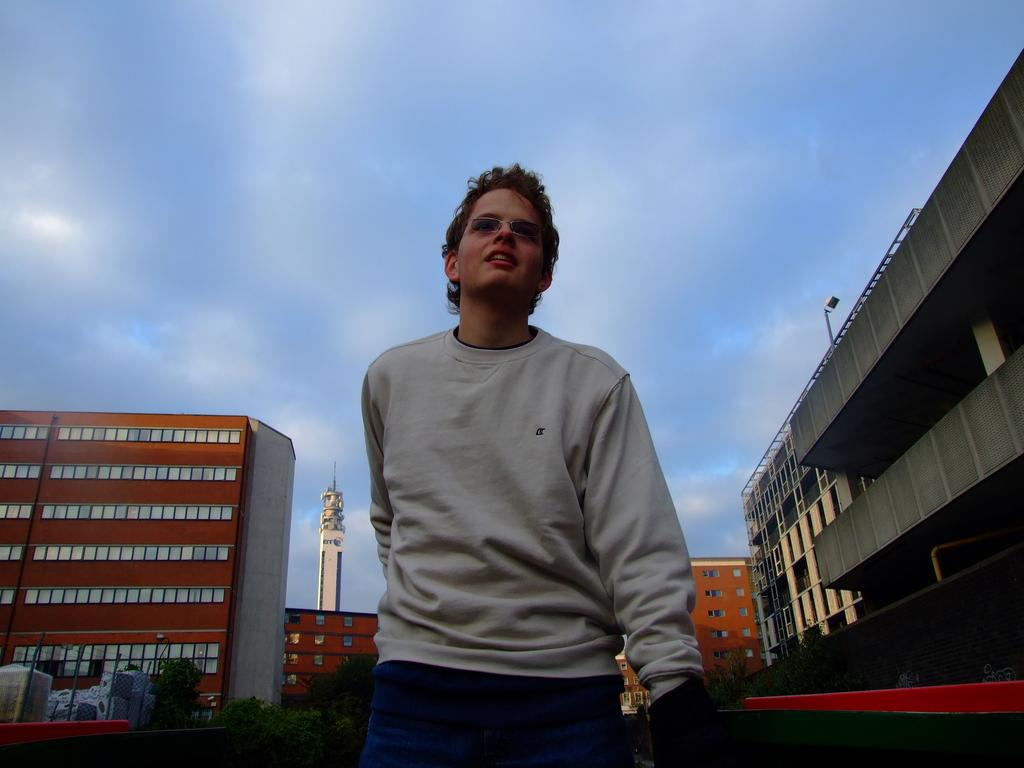What can be seen in the sky in the image? The sky is visible in the image. What is the tall structure in the image? There is a tower in the image. What type of structures are present in the image? There are buildings in the image. What type of vegetation is present in the image? Trees are present in the image. What are the poles used for in the image? The purpose of the poles is not specified in the image. Can you describe the man in the image? There is a man wearing spectacles in the image. What type of chain can be seen connecting the buildings in the image? There is no chain connecting the buildings in the image. 